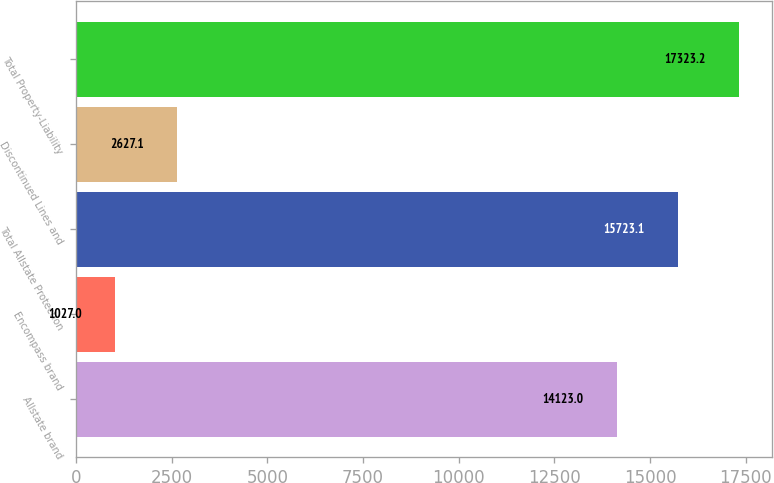Convert chart. <chart><loc_0><loc_0><loc_500><loc_500><bar_chart><fcel>Allstate brand<fcel>Encompass brand<fcel>Total Allstate Protection<fcel>Discontinued Lines and<fcel>Total Property-Liability<nl><fcel>14123<fcel>1027<fcel>15723.1<fcel>2627.1<fcel>17323.2<nl></chart> 